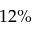<formula> <loc_0><loc_0><loc_500><loc_500>1 2 \%</formula> 